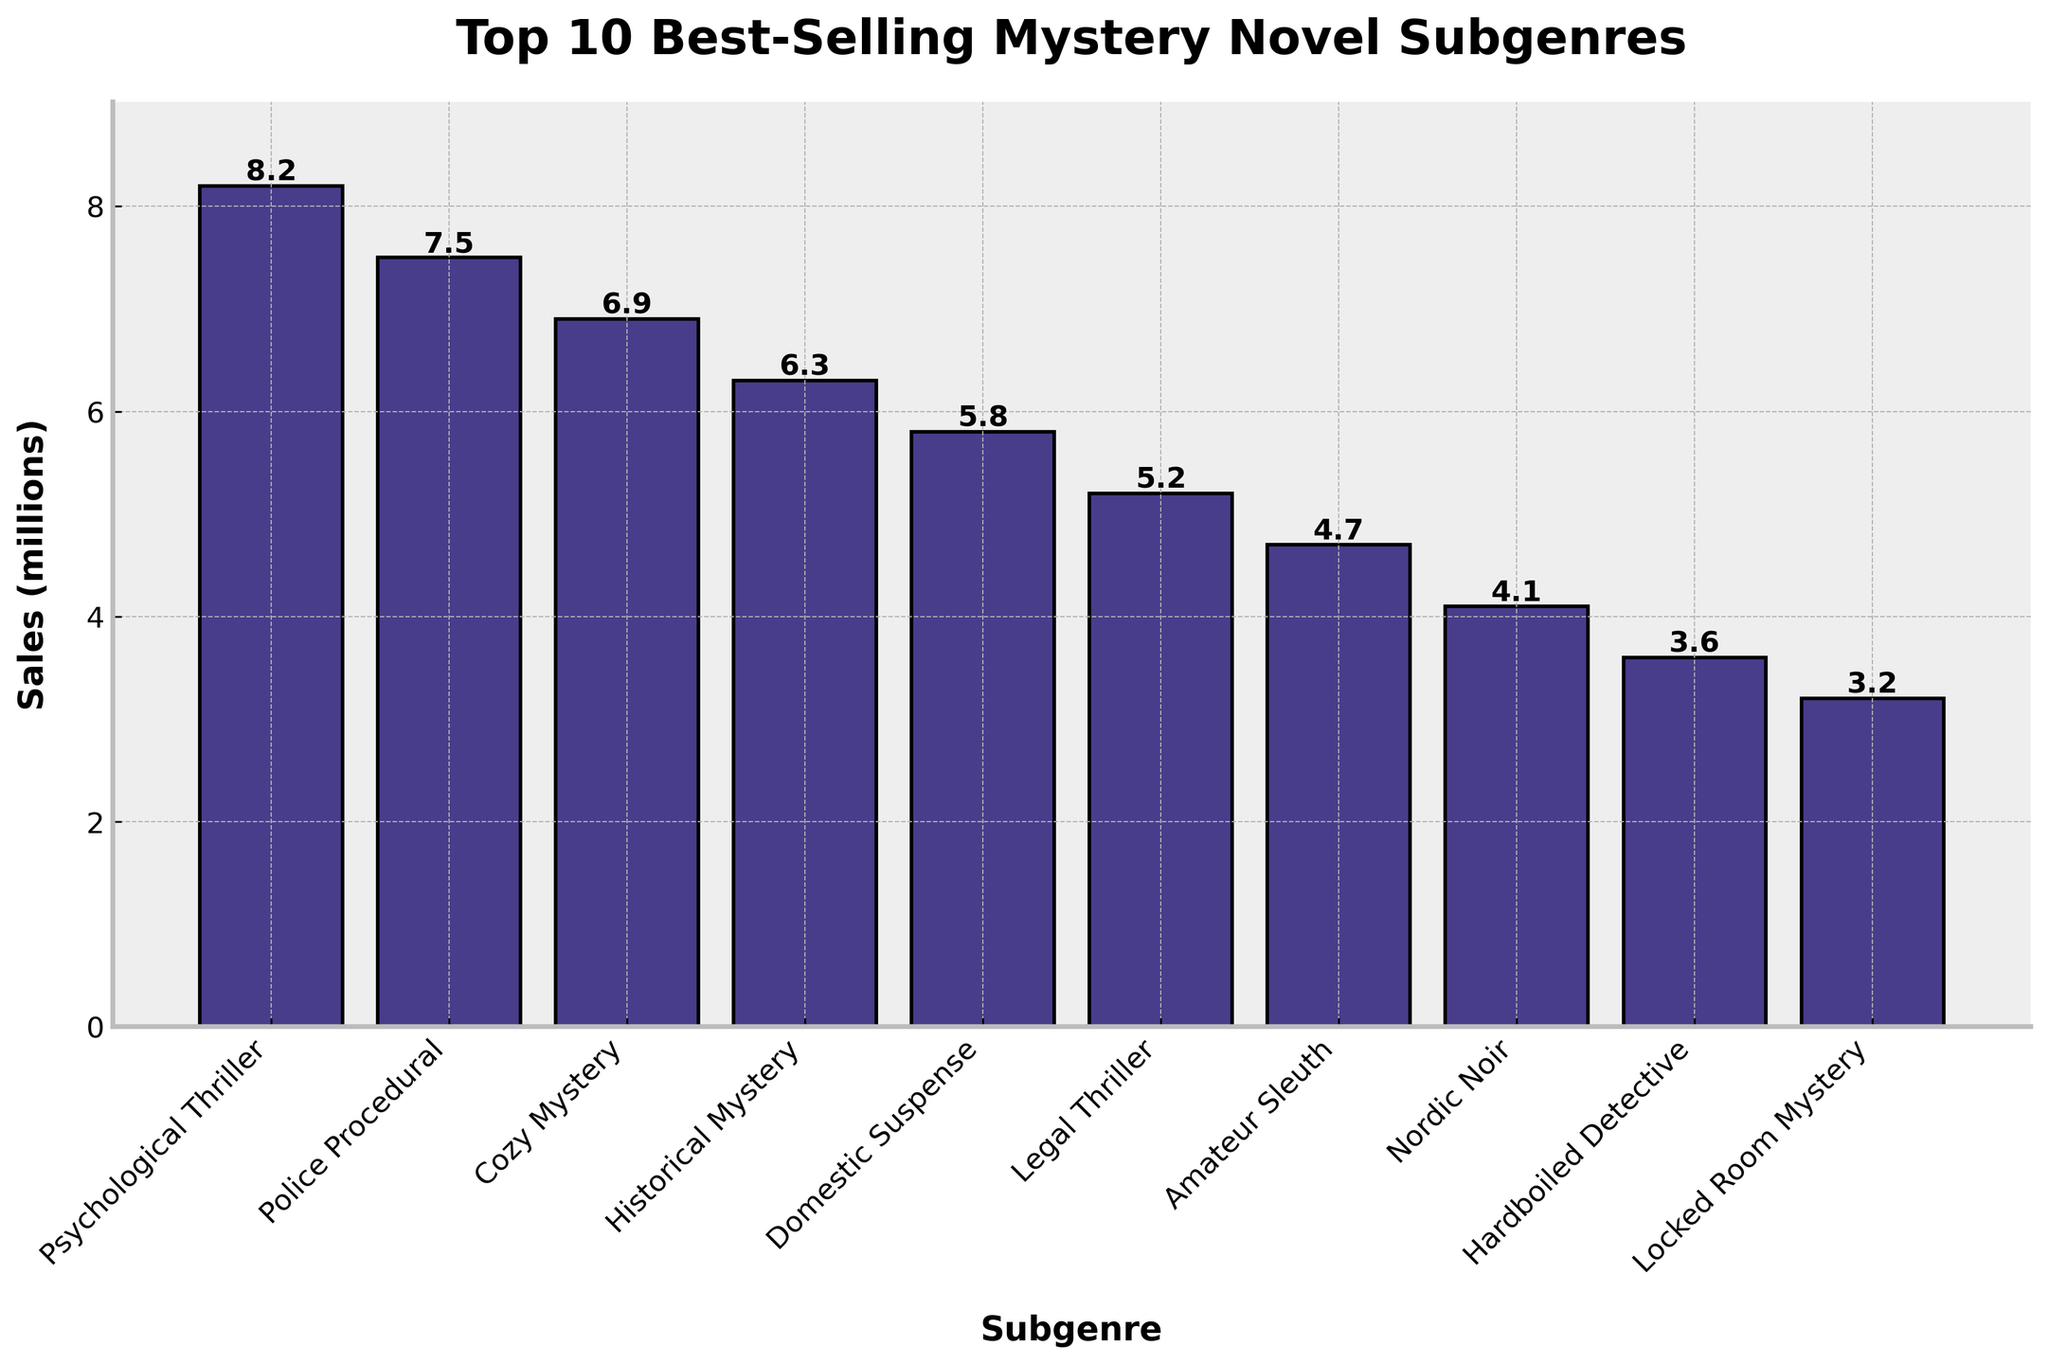Which subgenre has the highest sales? By observing the height of the bars in the chart, the bar representing "Psychological Thriller" is the tallest.
Answer: Psychological Thriller What is the difference in sales between "Psychological Thriller" and "Locked Room Mystery"? From the chart, the sales for "Psychological Thriller" are 8.2 million, and for "Locked Room Mystery" are 3.2 million. The difference is 8.2 - 3.2 = 5 million.
Answer: 5 million How many subgenres have sales above 6 million? By identifying the bars whose height goes above the 6 million mark, we find "Psychological Thriller", "Police Procedural", "Cozy Mystery", and "Historical Mystery". There are 4 subgenres.
Answer: 4 Which subgenre has sales closest to 5 million? By comparing the height of the bars to the 5 million mark, "Domestic Suspense" has sales of 5.8 million, which is closest to 5 million.
Answer: Domestic Suspense What is the combined sales of the top 3 best-selling subgenres? The top 3 subgenres by sales are "Psychological Thriller" (8.2 million), "Police Procedural" (7.5 million), and "Cozy Mystery" (6.9 million). The combined sales are 8.2 + 7.5 + 6.9 = 22.6 million.
Answer: 22.6 million Which subgenre has the shortest bar? By looking at the shortest bar in the chart, it corresponds to "Locked Room Mystery".
Answer: Locked Room Mystery Are there more subgenres with sales below or above 5 million? Count the number of subgenres with sales above 5 million (4 subgenres: "Psychological Thriller", "Police Procedural", "Cozy Mystery", "Historical Mystery") and below 5 million (6 subgenres: "Domestic Suspense", "Legal Thriller", "Amateur Sleuth", "Nordic Noir", "Hardboiled Detective", "Locked Room Mystery"). There are more subgenres with sales below 5 million.
Answer: Below 5 million What is the average sales of all subgenres? Sum the sales of all subgenres: 8.2 + 7.5 + 6.9 + 6.3 + 5.8 + 5.2 + 4.7 + 4.1 + 3.6 + 3.2 = 55.5. Divide by the number of subgenres (10). The average sales are 55.5 / 10 = 5.55 million.
Answer: 5.55 million Which subgenre's sales is exactly the median when all subgenres are ordered by sales? To find the median, order the sales data: 3.2, 3.6, 4.1, 4.7, 5.2, 5.8, 6.3, 6.9, 7.5, 8.2. The median value is the average of the 5th and 6th values: (5.2 + 5.8) / 2 = 5.5 million. Since no subgenre has exactly 5.5 million, this falls between "Legal Thriller" and "Domestic Suspense".
Answer: Between Legal Thriller and Domestic Suspense 